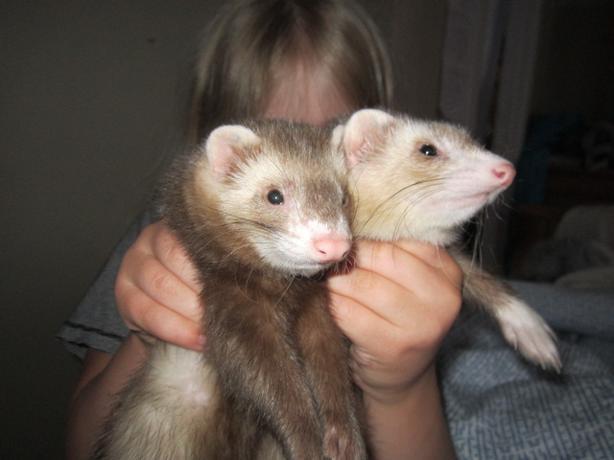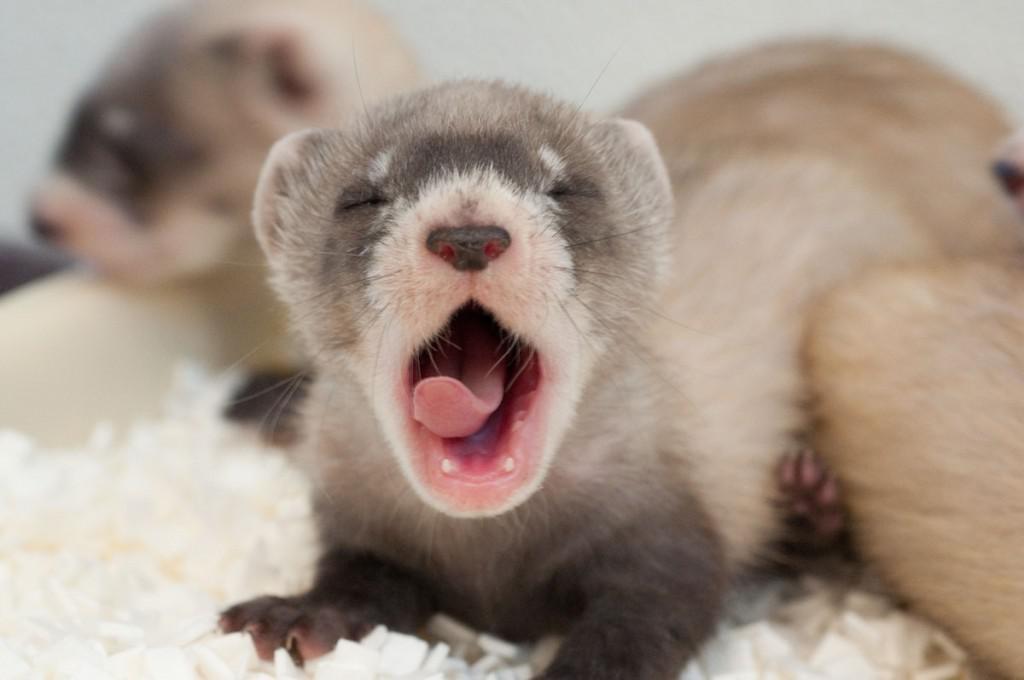The first image is the image on the left, the second image is the image on the right. Assess this claim about the two images: "In one image, a little animal is facing forward with its mouth wide open and tongue showing, while a second image shows two similar animals in different colors.". Correct or not? Answer yes or no. Yes. The first image is the image on the left, the second image is the image on the right. Evaluate the accuracy of this statement regarding the images: "A pair of ferrets are held side-by-side in a pair of human hands.". Is it true? Answer yes or no. Yes. 